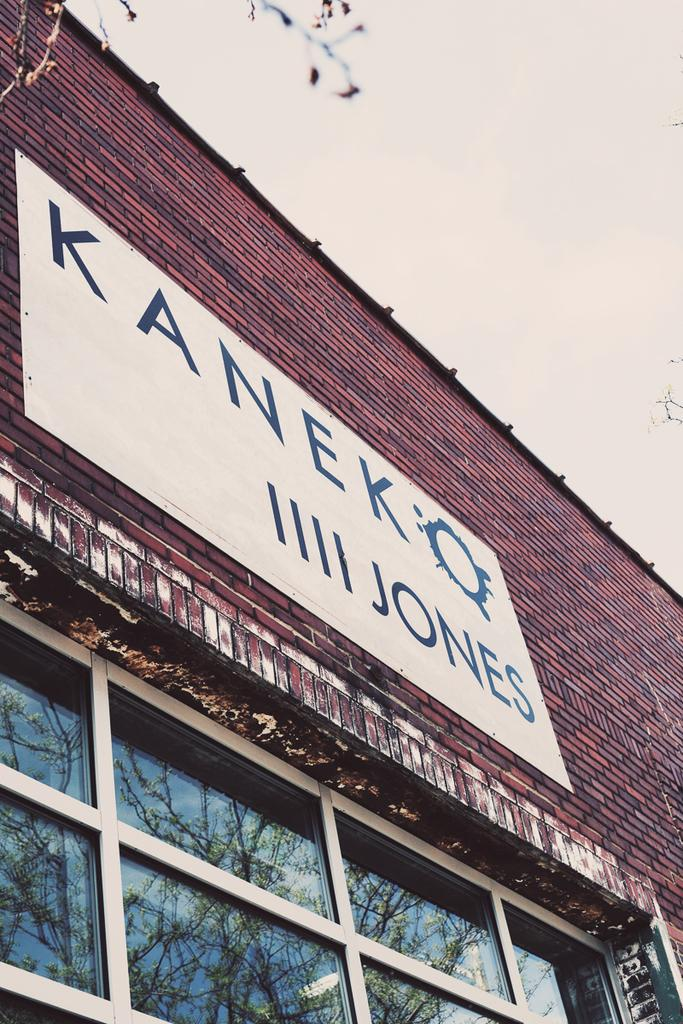What type of structure is present in the image? There is a building in the image. Can you describe any specific features of the building? The building has a window on the bottom. What is located above the window? There is a name board above the window. What can be seen at the top of the image? The sky is visible at the top of the image. Is there a throne made of gold inside the building in the image? There is no throne visible in the image, and no information is provided about the interior of the building. 